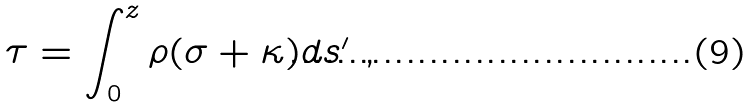Convert formula to latex. <formula><loc_0><loc_0><loc_500><loc_500>\tau = \int _ { 0 } ^ { z } \rho ( \sigma + \kappa ) d s ^ { \prime } \ ,</formula> 